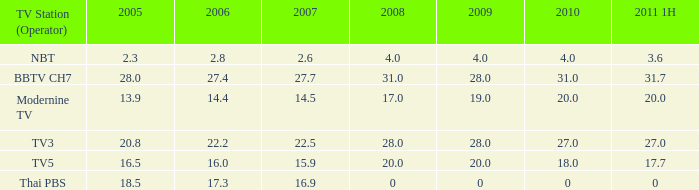What is the number of 2008 values having a 2006 under 17.3, 2010 over 4, and 2011 1H of 20? 1.0. 